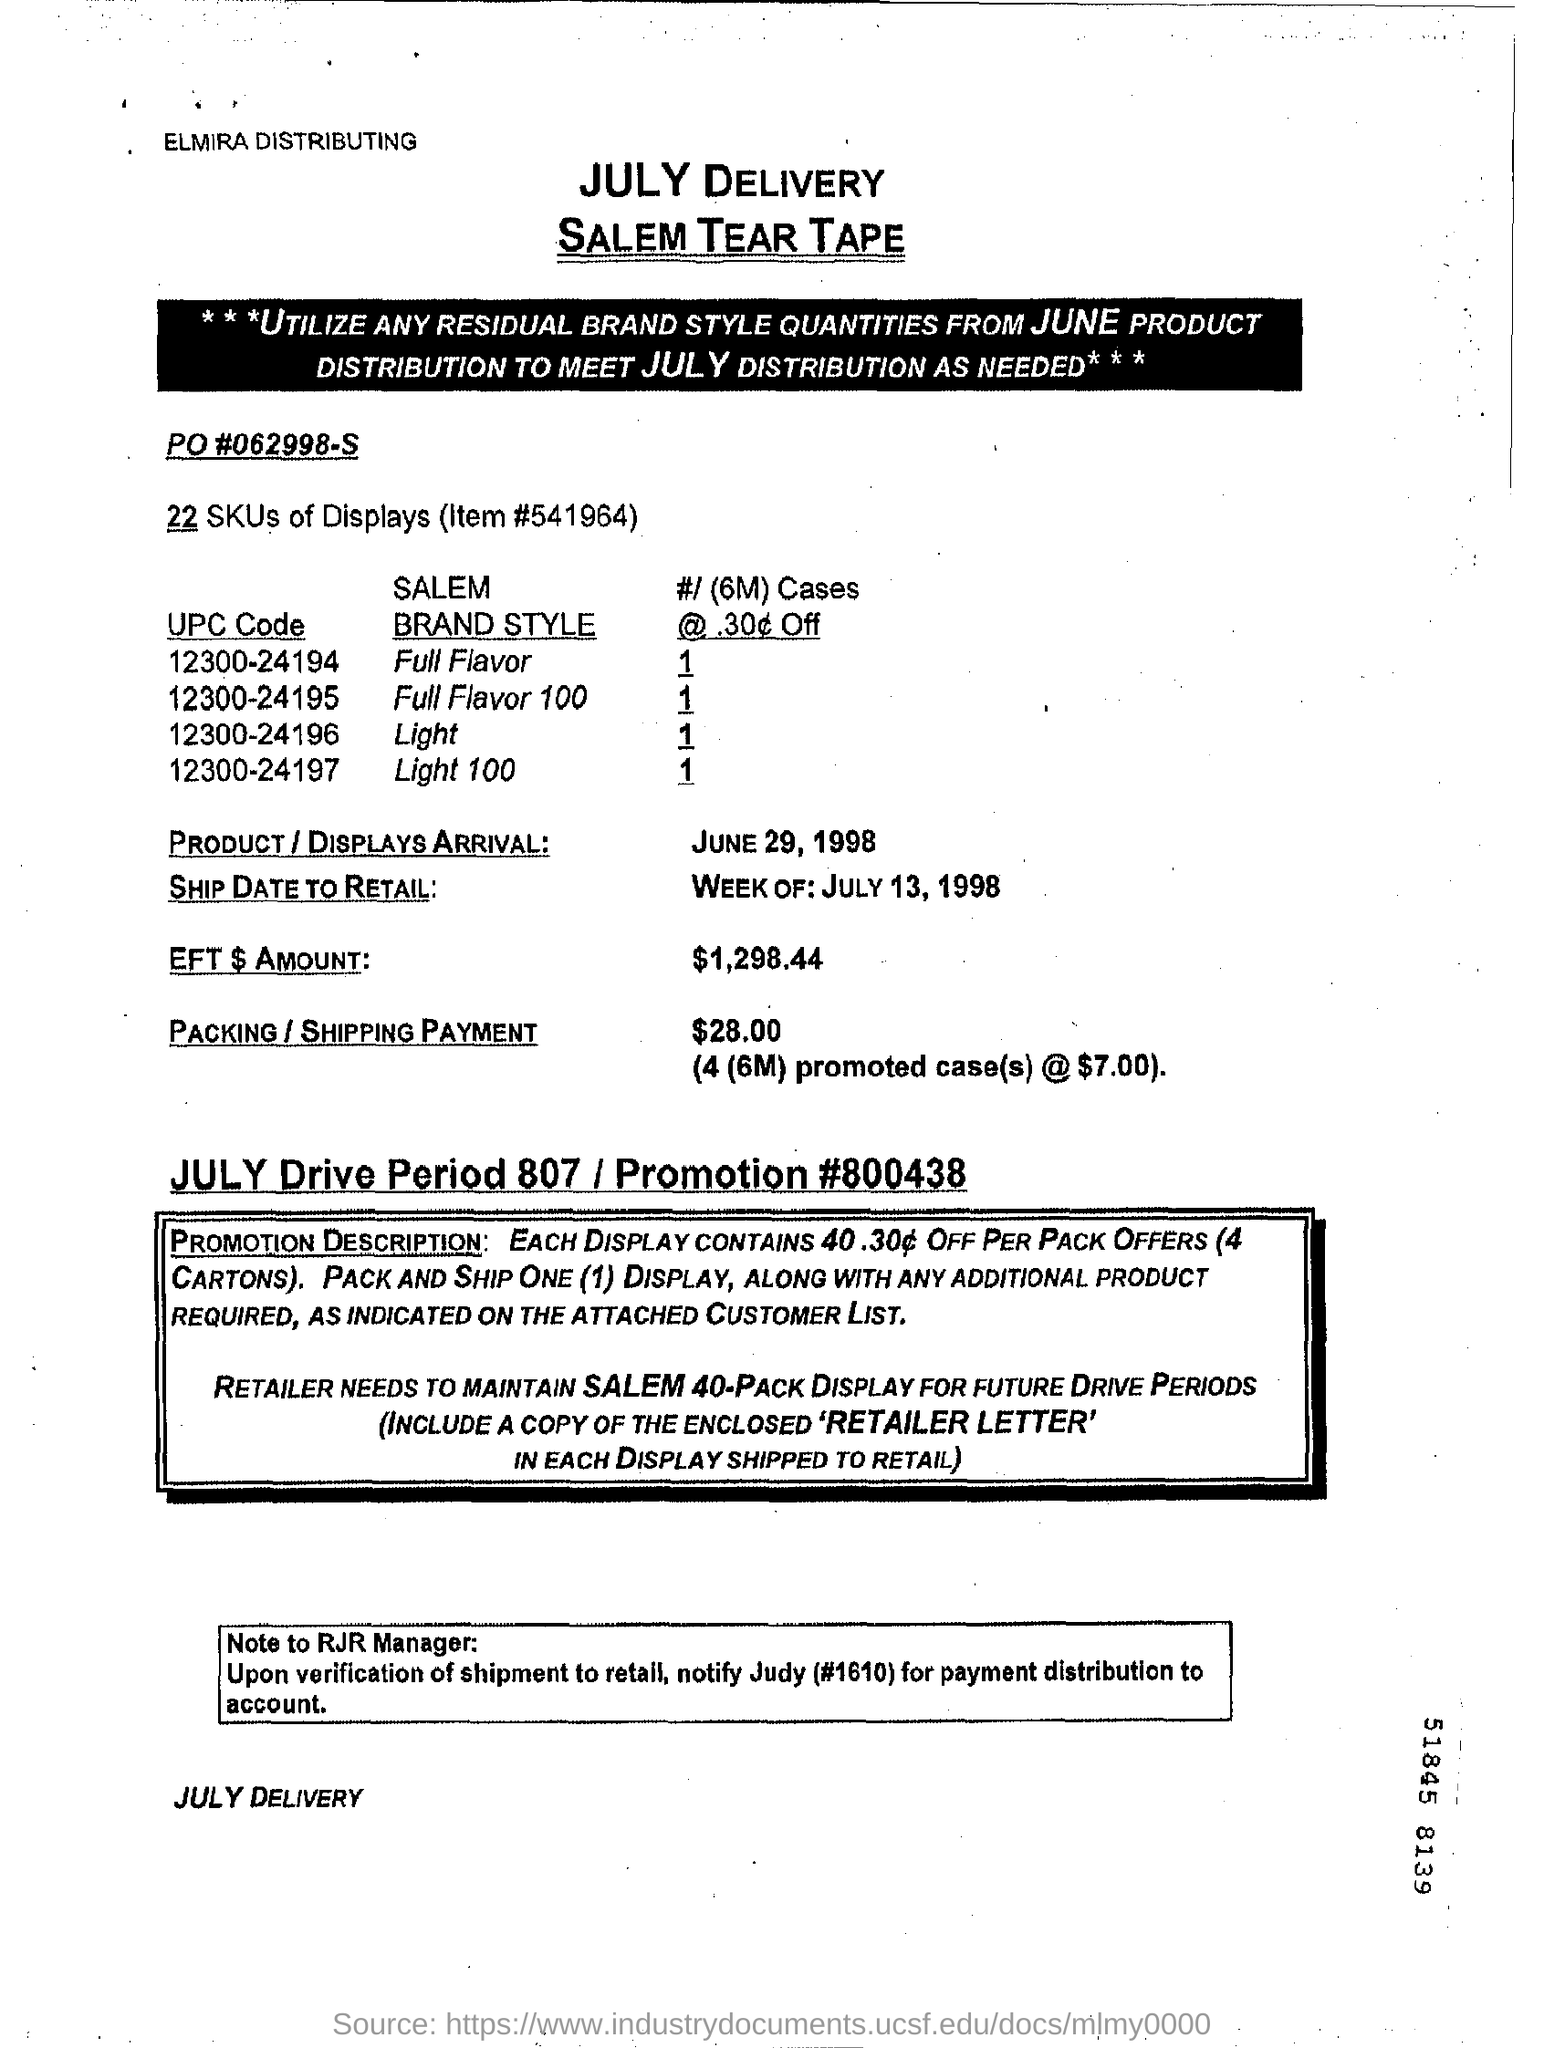What is the Item #?
Your response must be concise. 541964. When is the Product / Displays Arrival?
Your answer should be compact. June 29, 1998. When is the Ship Date to Retail?
Your response must be concise. Week of : july 13 , 1998. What is the EFT $ Amount?
Offer a terse response. $1,298.44. How much is the Packing /Shipping Payment?
Offer a very short reply. $28.00 (4(6M) promoted case(s) @$7.00). What is the Promotion #?
Ensure brevity in your answer.  800438. 